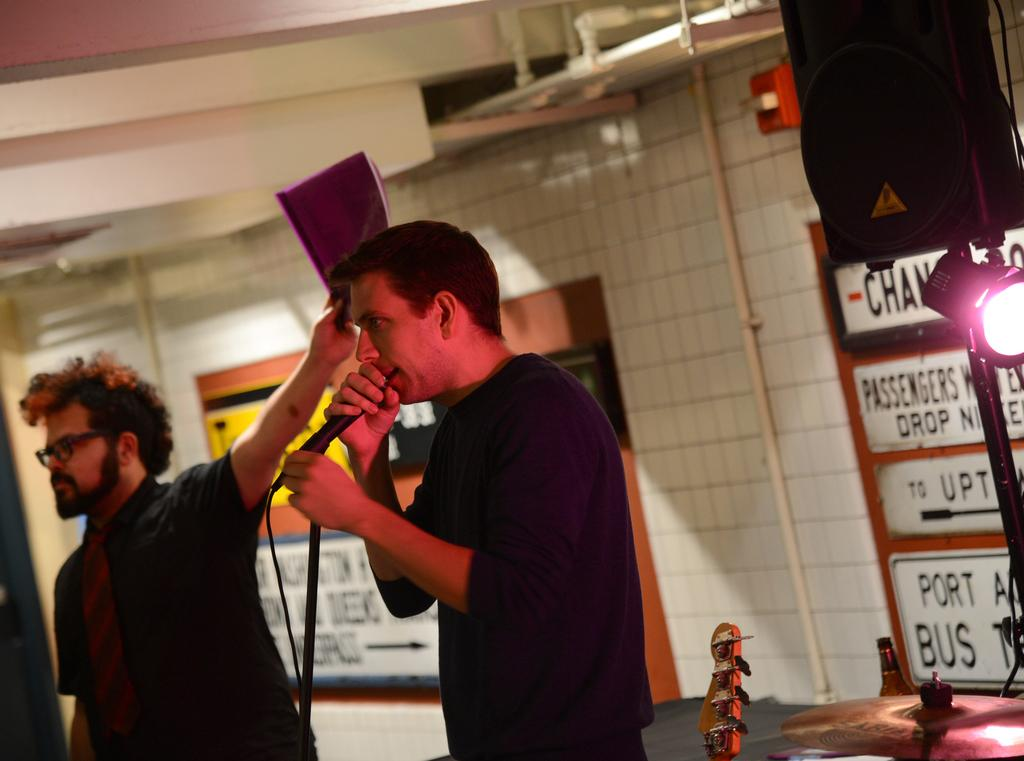What is the person in the blue shirt doing in the image? The person is standing and singing in the image. What object is the person in front of? The person is in front of a microphone. Can you describe the second person in the image? The second person is also standing, and he is holding a file in his hand. Can you see any wings on the person singing in the image? No, there are no wings visible on the person singing in the image. What is the sun doing in the image? There is no sun present in the image; it is an indoor scene. 